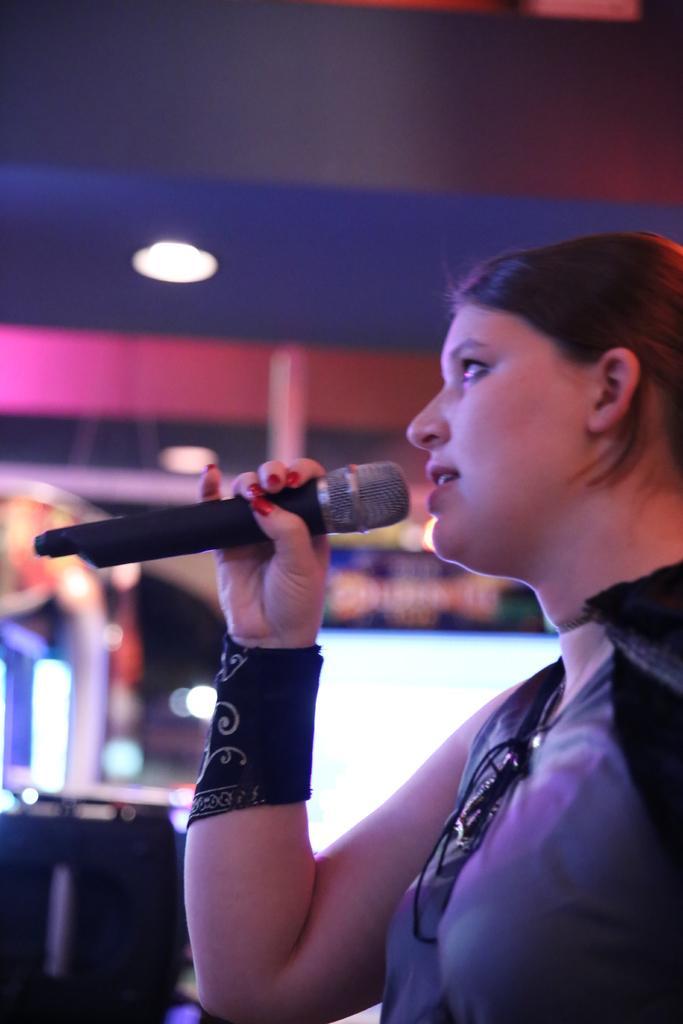Can you describe this image briefly? As we can see in the image there is a woman holding mike in her hand. 